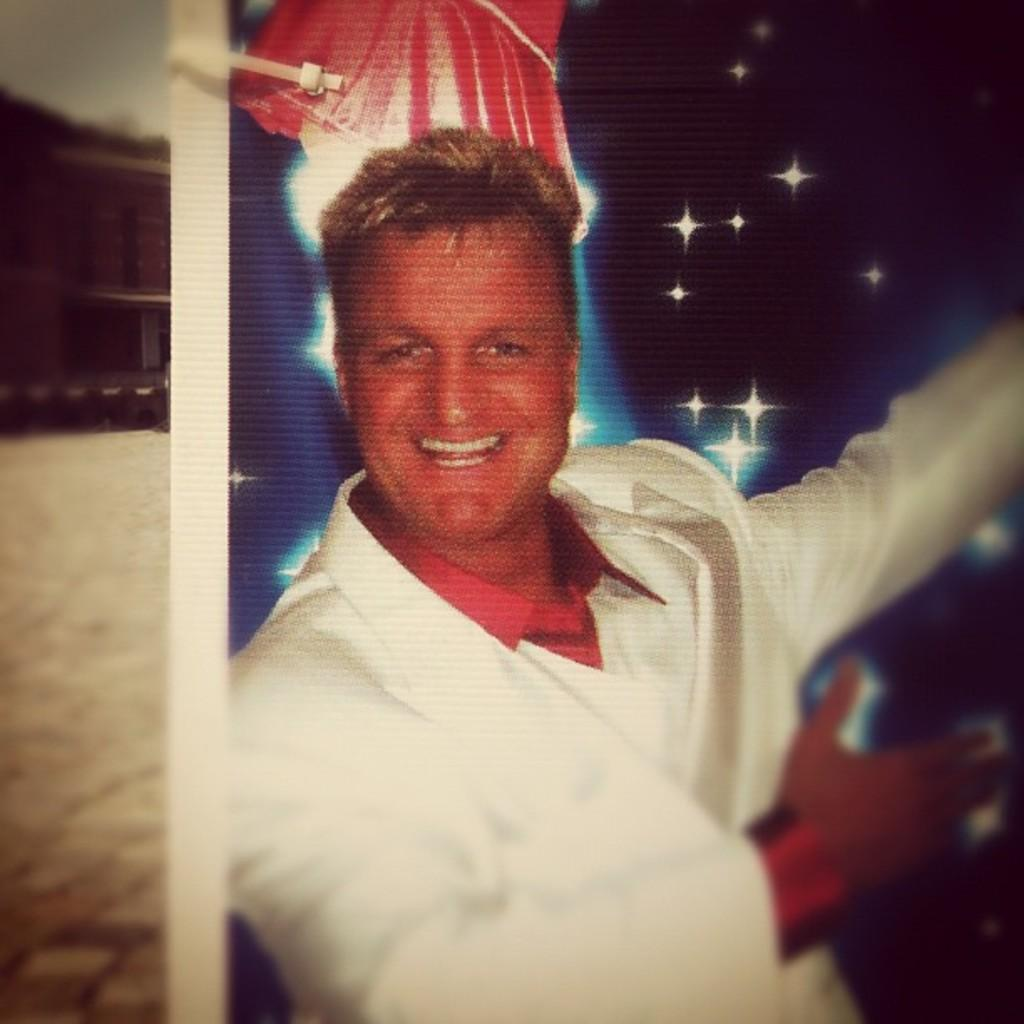Who is in the photo that is visible in the image? There is a photo of a man in the image. What expression does the man have in the photo? The man is smiling in the photo. What can be seen behind the man in the photo? There is a background in the image, which includes the ground, a building, and the sky. What type of thread is being used to sew the man's clothes in the image? There is no thread visible in the image, as it is a photo of a man and not a depiction of him being sewn. 